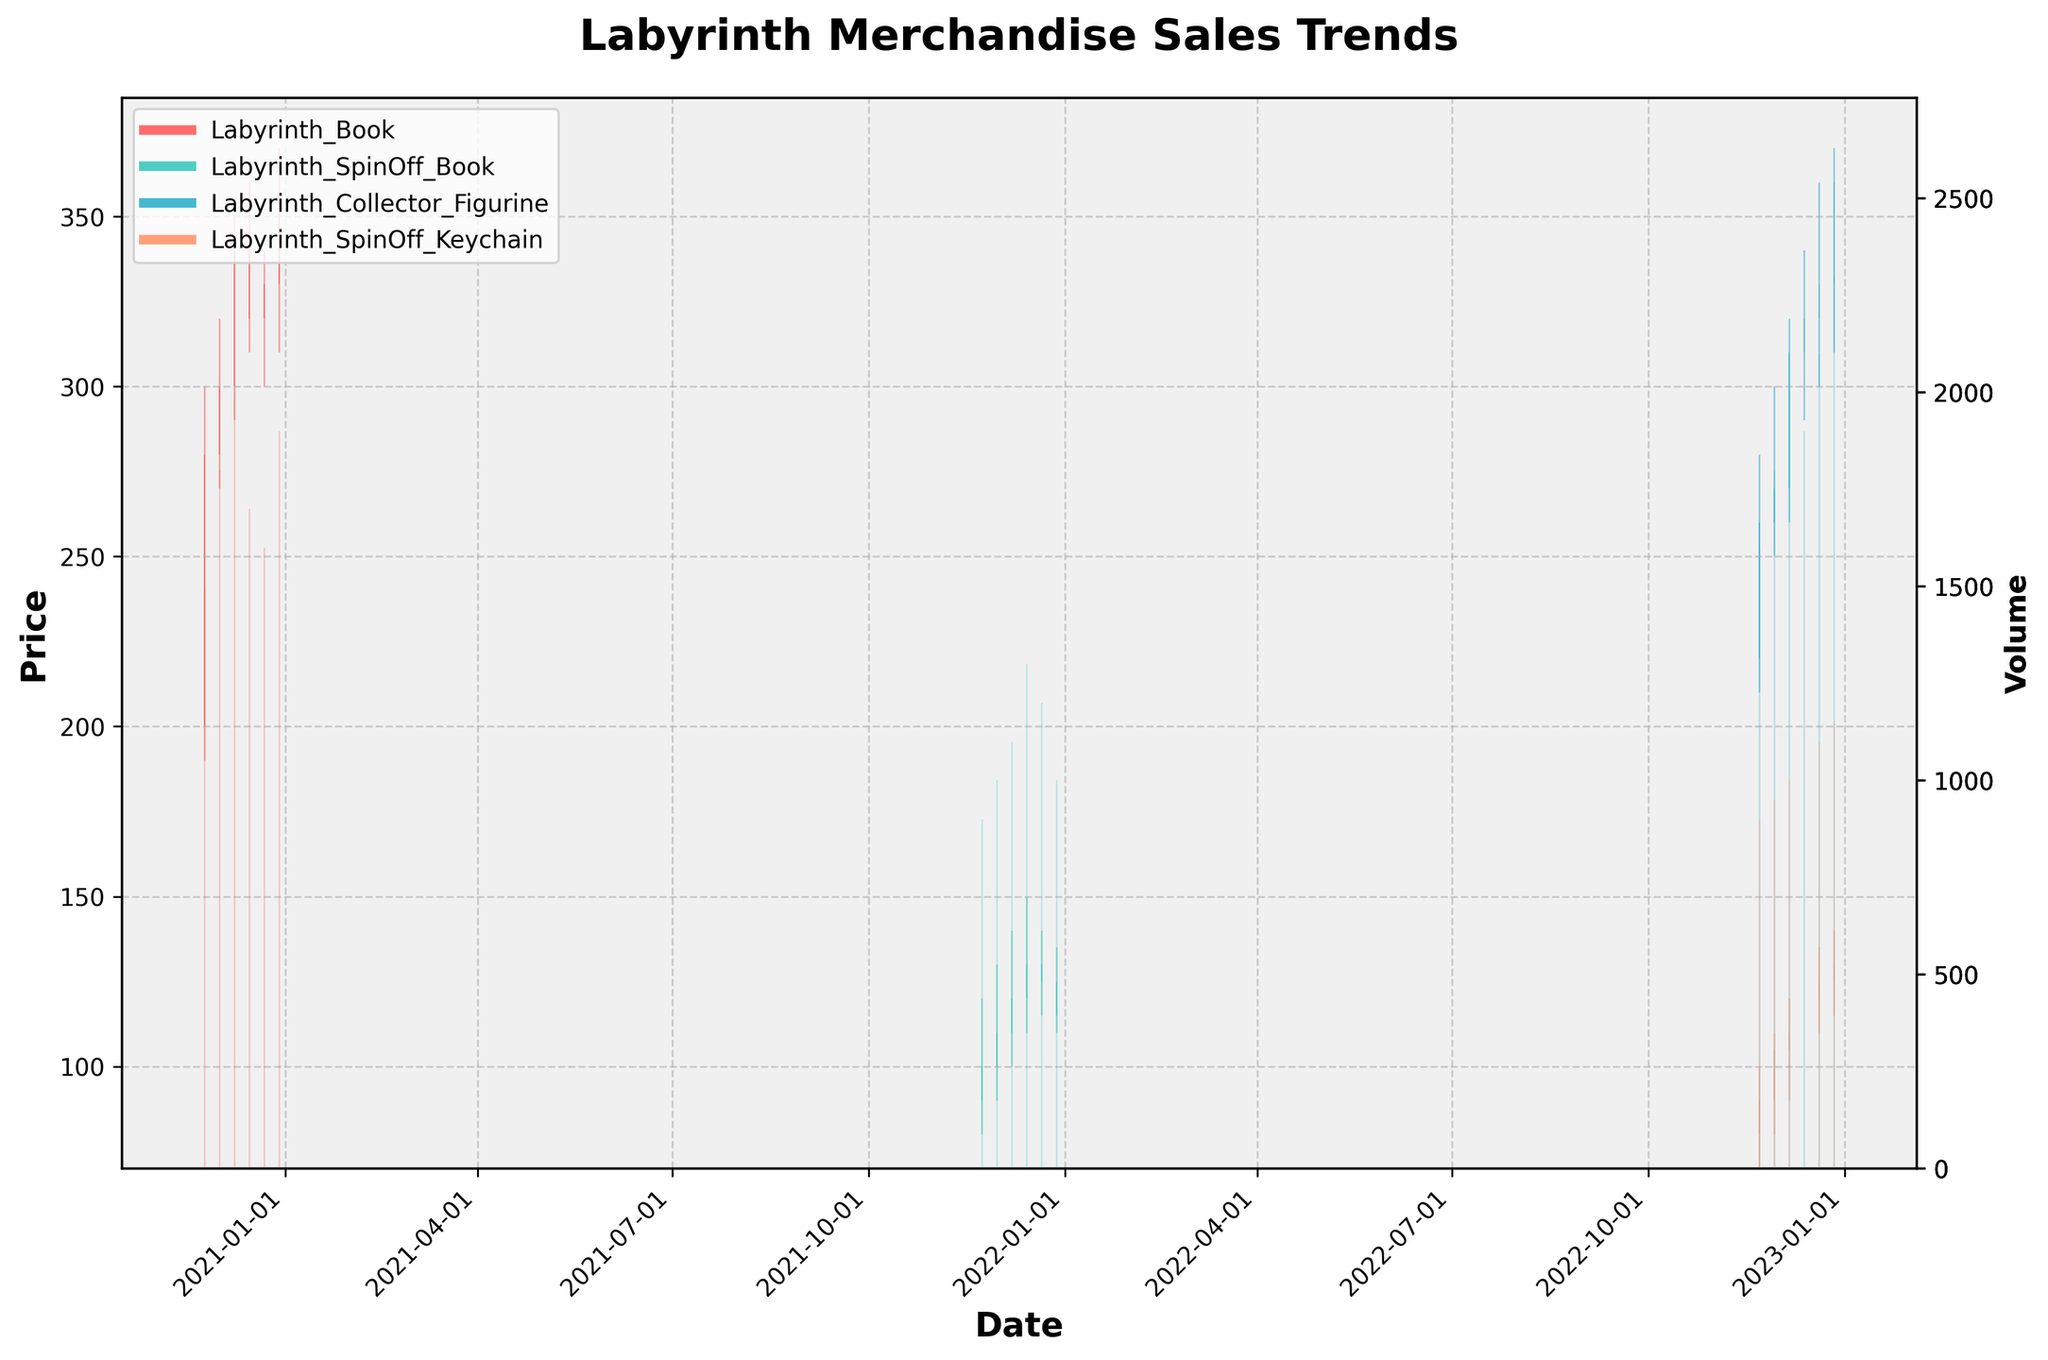What are the items shown in the plot? The title of the plot indicates it is about "Labyrinth Merchandise Sales Trends," and in the figure legend, you can see the different items listed. They are "Labyrinth Book," "Labyrinth SpinOff Book," "Labyrinth Collector Figurine," and "Labyrinth SpinOff Keychain."
Answer: Labyrinth Book, Labyrinth SpinOff Book, Labyrinth Collector Figurine, Labyrinth SpinOff Keychain What is the highest closing price for the "Labyrinth Book"? The plot shows candlesticks where the closing prices are marked by the top or bottom of the thicker part of the candlestick, i.e., the close value. The “Labyrinth Book” line can be identified through its color code. The highest closing price appears to be around 350 on 2020-12-29.
Answer: 350 How did the sales volume of the "Labyrinth SpinOff Book" change over the holiday season? By looking at the secondary Y-axis on the right, which represents volume, and correlating it with the color of the "Labyrinth SpinOff Book," you can observe that the volume bars start at 900 and increase gradually to 1300, then slightly decrease to around 1000 by the end of the period.
Answer: Increased then decreased Which item had the highest volume during the given periods? To find the highest volume, check the tallest volume bars across all items. The "Labyrinth Collector Figurine" seems to have the highest volume bar around 2300.
Answer: Labyrinth Collector Figurine By how much did the closing price of the "Labyrinth SpinOff Keychain" increase from 2022-12-06 to 2022-12-27? Locate the closing prices for the given dates through the candlestick’s thicker part (upper for increase, and lower for decrease). The close on 2022-12-06 is 110 and on 2022-12-27 is 130. The increase is 130 - 110 = 20.
Answer: 20 Between which two dates did the "Labyrinth Collector Figurine" see the largest drop in closing price? By observing the candlesticks, you can see that between 2022-12-06 and 2022-12-13, the closing price dropped from 310 to 320, a significant drop compared to other date sets for this item.
Answer: 2022-12-06 to 2022-12-13 How does the highest high price of "Labyrinth SpinOff Book" compare to the lowest low price of "Labyrinth Book"? The highest point for "Labyrinth SpinOff Book" can be found at its highest candlestick top, which is 150. For "Labyrinth Book," the lowest low point is at the bottom of its candlestick, which is 190. Thus, 150 is lower than 190.
Answer: Less than What is the average closing price of the "Labyrinth Collector Figurine" over the given period? The closing prices for the "Labyrinth Collector Figurine" on its candlesticks are 260, 270, 310, 320, 330, and 360. To calculate the average: (260 + 270 + 310 + 320 + 330 + 360) / 6 = 1850 / 6.
Answer: 308.33 